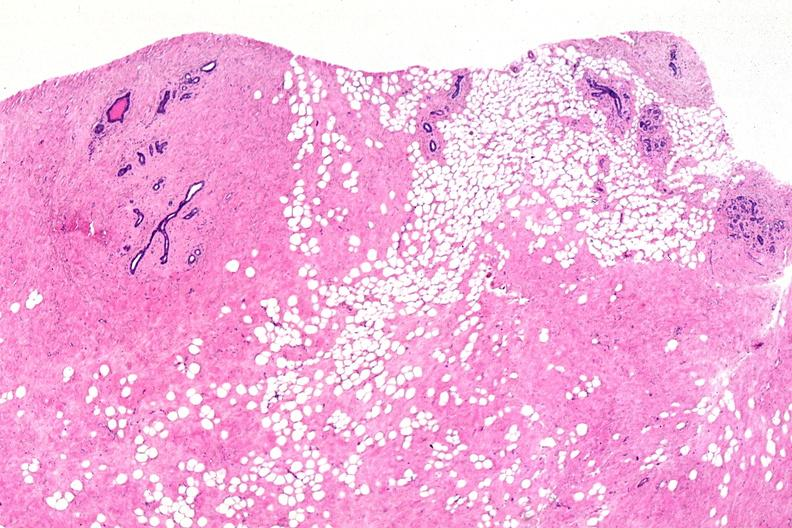what is present?
Answer the question using a single word or phrase. Female reproductive 